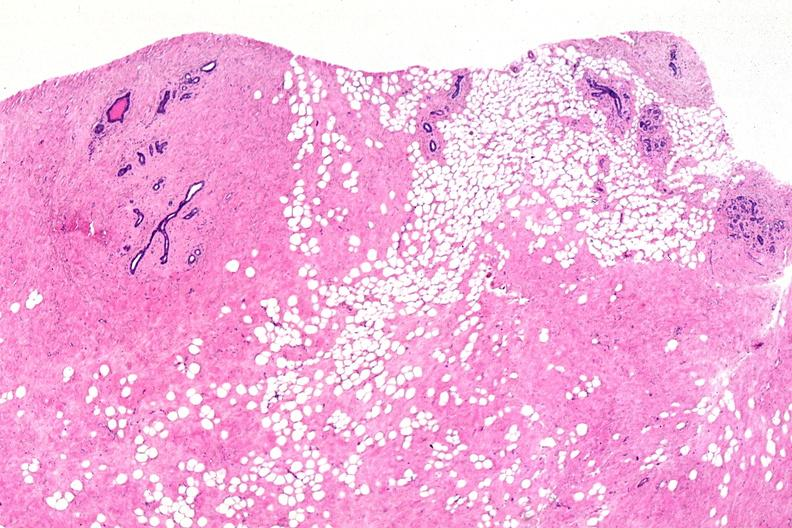what is present?
Answer the question using a single word or phrase. Female reproductive 